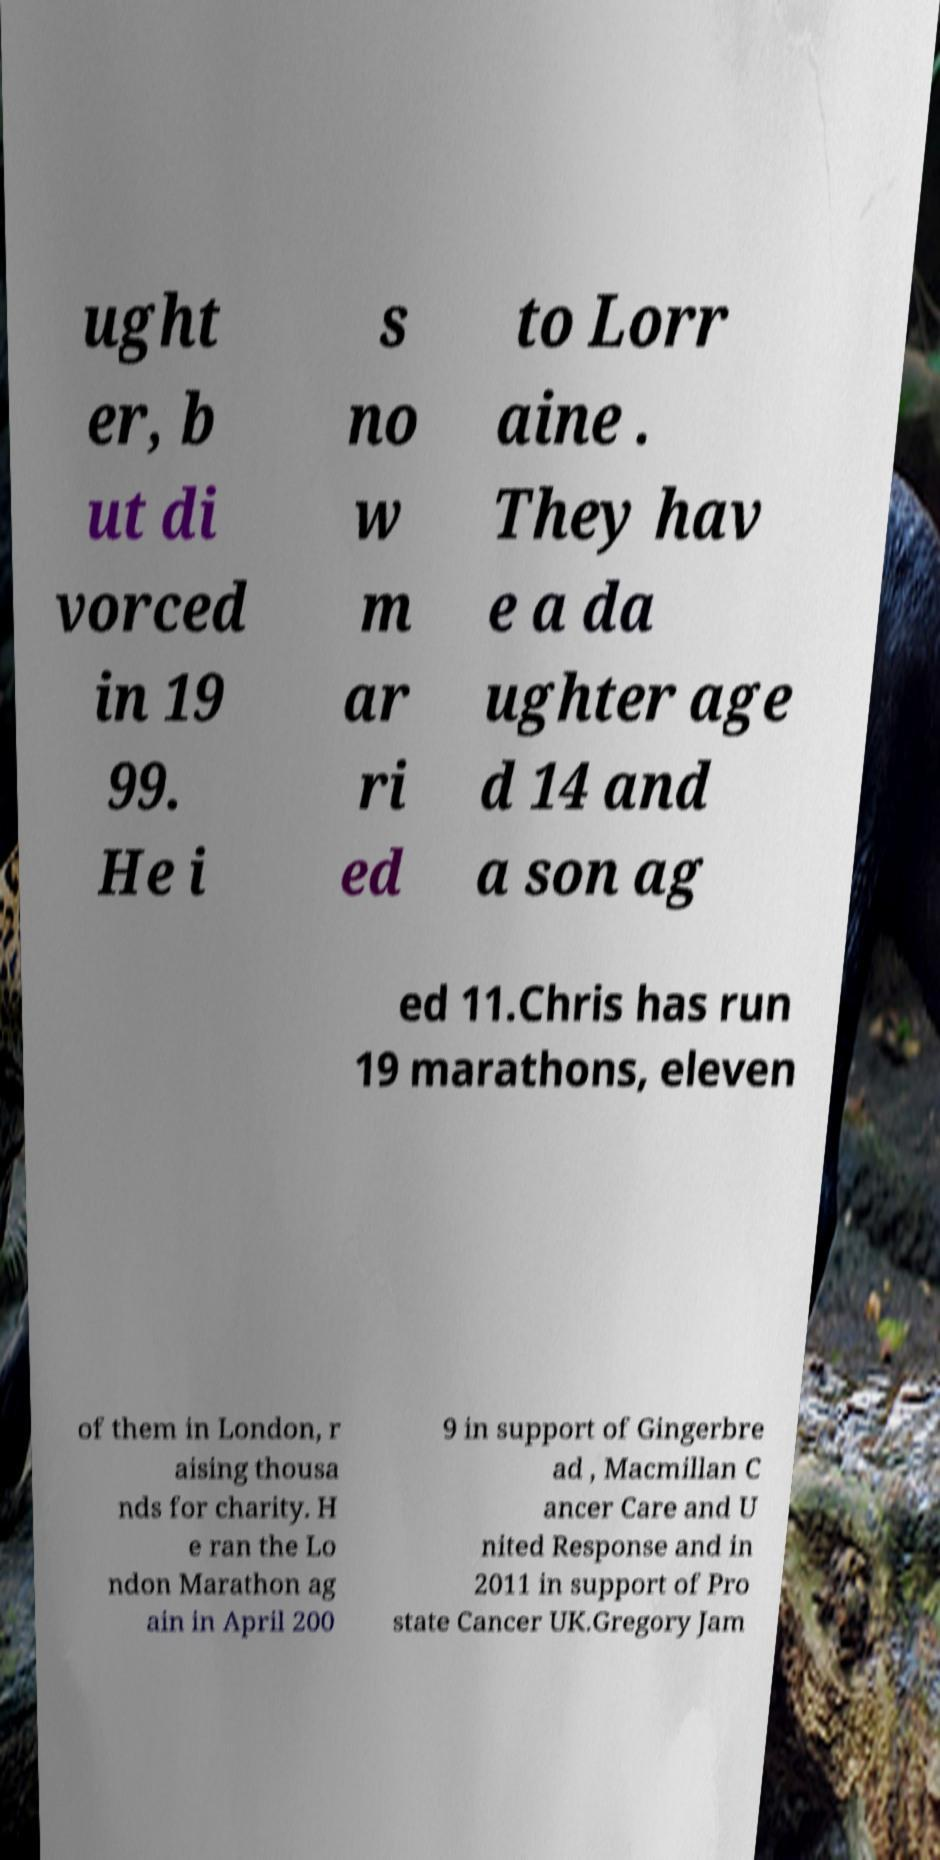Could you extract and type out the text from this image? ught er, b ut di vorced in 19 99. He i s no w m ar ri ed to Lorr aine . They hav e a da ughter age d 14 and a son ag ed 11.Chris has run 19 marathons, eleven of them in London, r aising thousa nds for charity. H e ran the Lo ndon Marathon ag ain in April 200 9 in support of Gingerbre ad , Macmillan C ancer Care and U nited Response and in 2011 in support of Pro state Cancer UK.Gregory Jam 